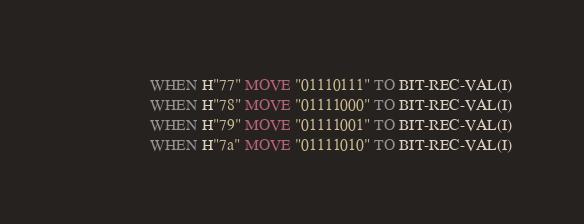Convert code to text. <code><loc_0><loc_0><loc_500><loc_500><_COBOL_>                   WHEN H"77" MOVE "01110111" TO BIT-REC-VAL(I)
                   WHEN H"78" MOVE "01111000" TO BIT-REC-VAL(I)
                   WHEN H"79" MOVE "01111001" TO BIT-REC-VAL(I)
                   WHEN H"7a" MOVE "01111010" TO BIT-REC-VAL(I)</code> 